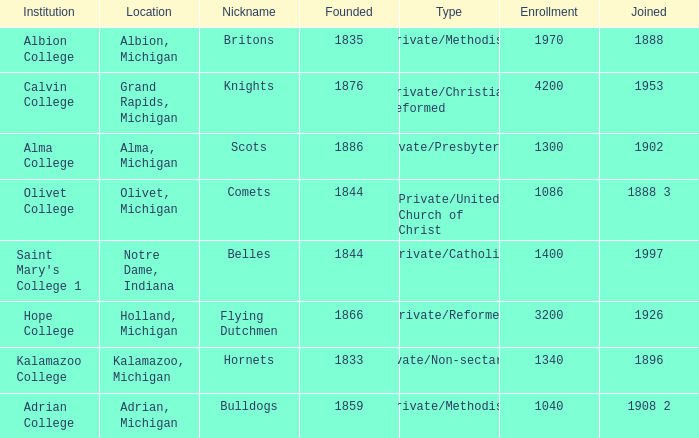In 1833, how many institutions were created? 1.0. Could you parse the entire table as a dict? {'header': ['Institution', 'Location', 'Nickname', 'Founded', 'Type', 'Enrollment', 'Joined'], 'rows': [['Albion College', 'Albion, Michigan', 'Britons', '1835', 'Private/Methodist', '1970', '1888'], ['Calvin College', 'Grand Rapids, Michigan', 'Knights', '1876', 'Private/Christian Reformed', '4200', '1953'], ['Alma College', 'Alma, Michigan', 'Scots', '1886', 'Private/Presbyterian', '1300', '1902'], ['Olivet College', 'Olivet, Michigan', 'Comets', '1844', 'Private/United Church of Christ', '1086', '1888 3'], ["Saint Mary's College 1", 'Notre Dame, Indiana', 'Belles', '1844', 'Private/Catholic', '1400', '1997'], ['Hope College', 'Holland, Michigan', 'Flying Dutchmen', '1866', 'Private/Reformed', '3200', '1926'], ['Kalamazoo College', 'Kalamazoo, Michigan', 'Hornets', '1833', 'Private/Non-sectarian', '1340', '1896'], ['Adrian College', 'Adrian, Michigan', 'Bulldogs', '1859', 'Private/Methodist', '1040', '1908 2']]} 